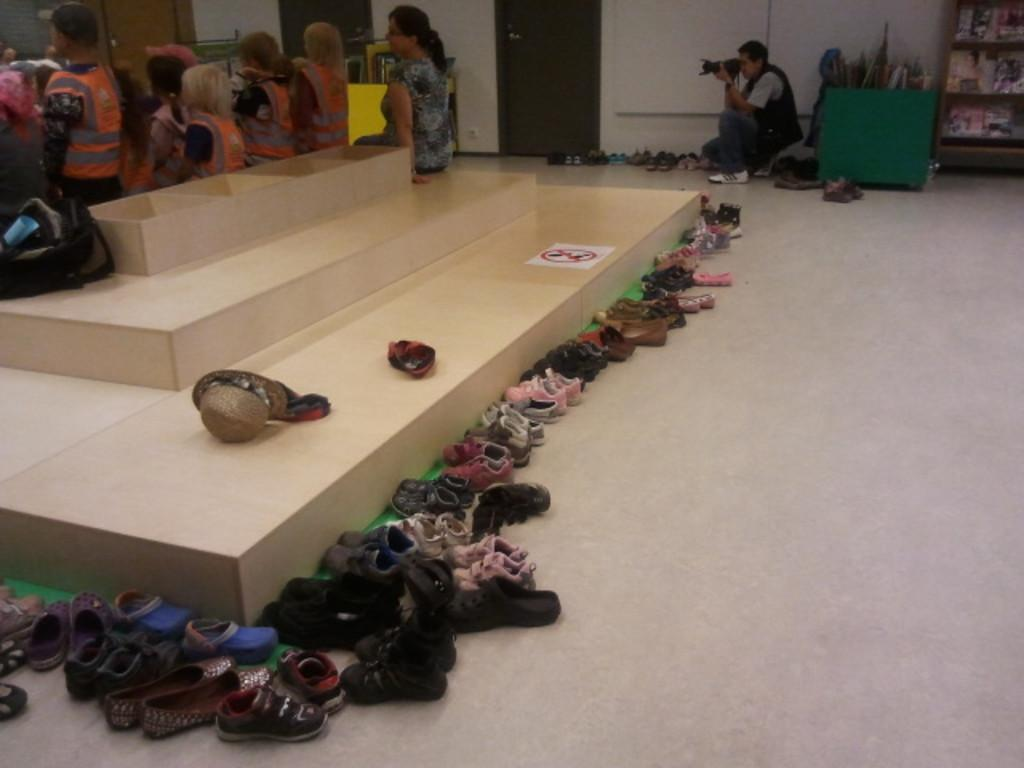What is placed on the floor in the image? There is footwear placed on the floor in the image. What are the persons in the background of the image doing? The persons in the background of the image are sitting on the floor. Can you describe the activity of one of the persons in the image? One of the persons is holding a camera in their hands. What type of fang can be seen in the image? There is no fang present in the image. What kind of badge is being worn by the person holding the camera? There is no badge visible in the image. 